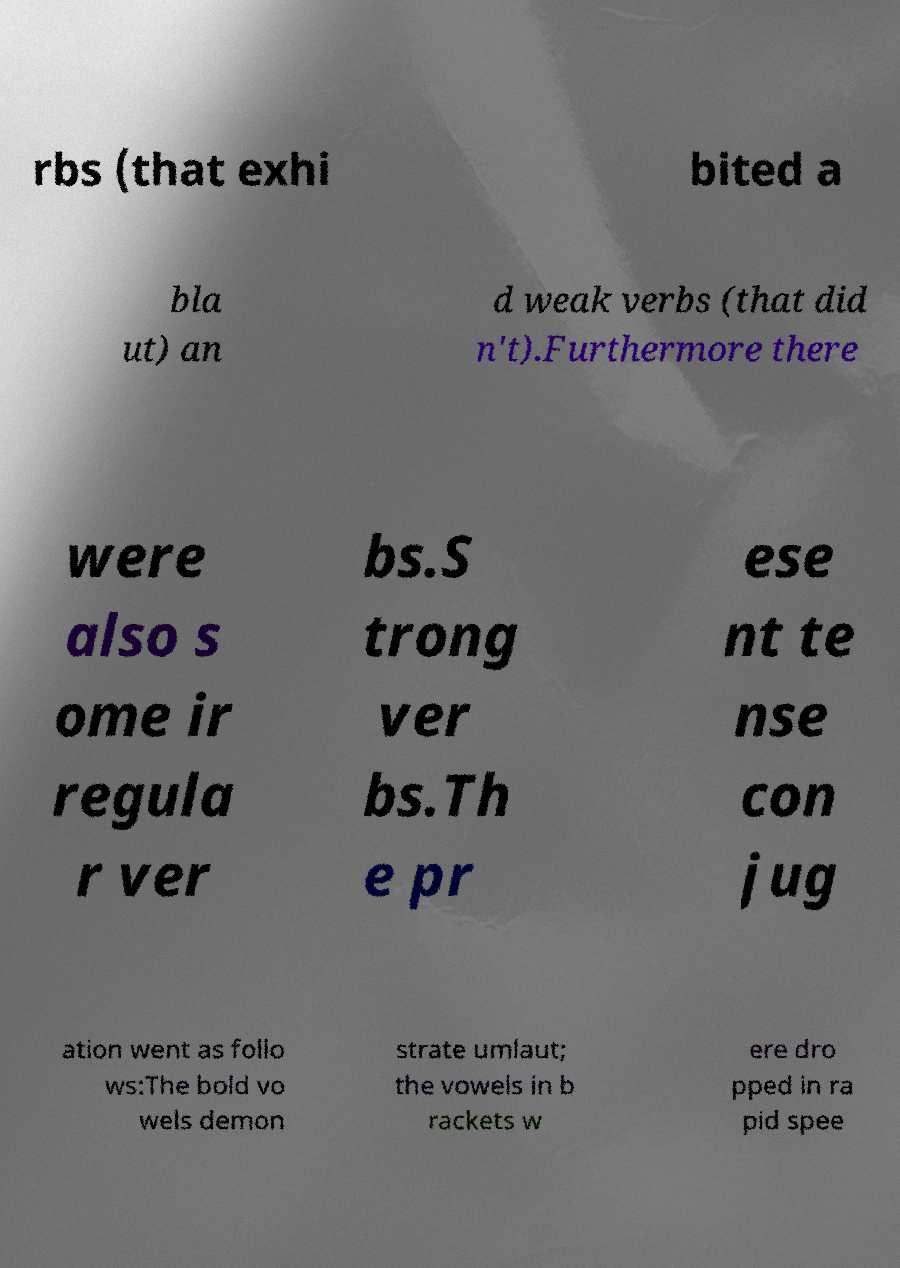Please identify and transcribe the text found in this image. rbs (that exhi bited a bla ut) an d weak verbs (that did n't).Furthermore there were also s ome ir regula r ver bs.S trong ver bs.Th e pr ese nt te nse con jug ation went as follo ws:The bold vo wels demon strate umlaut; the vowels in b rackets w ere dro pped in ra pid spee 